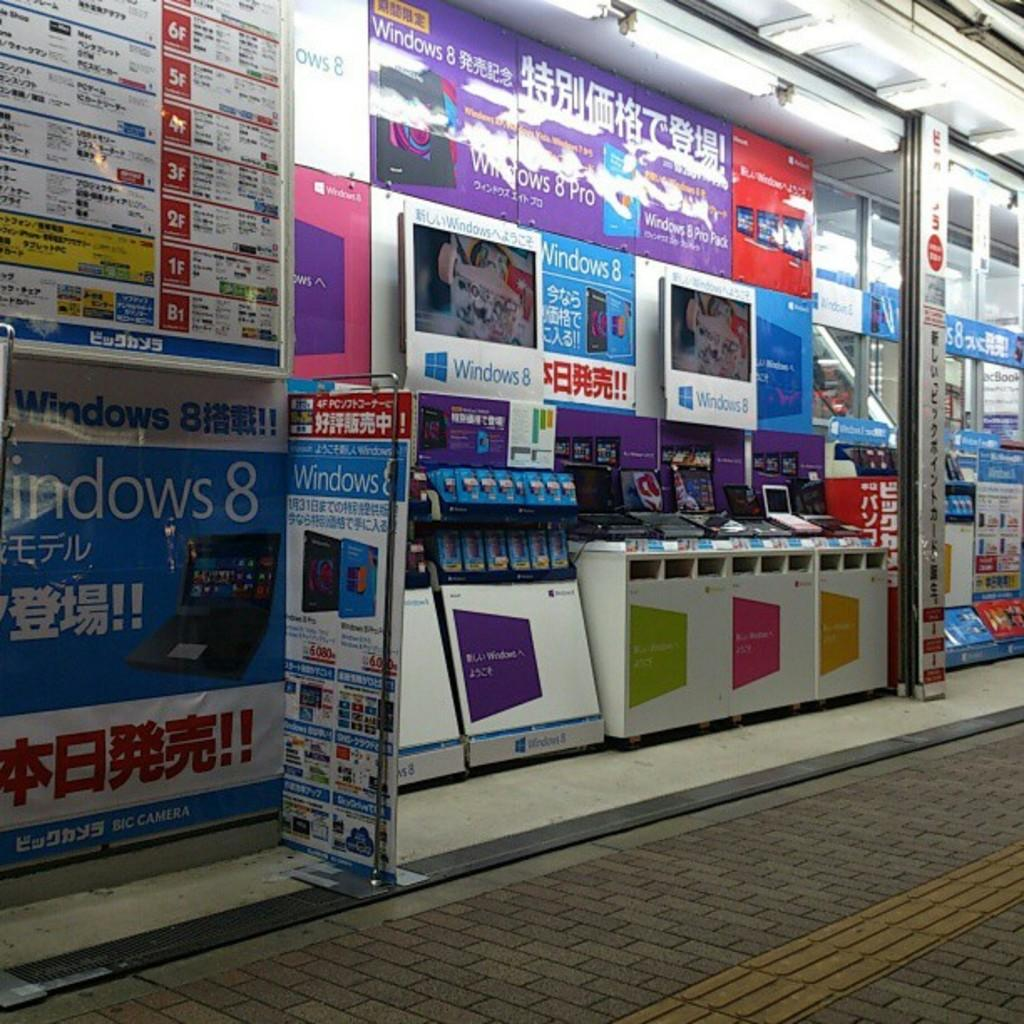<image>
Present a compact description of the photo's key features. A Windows 8 ad is on a wall covered in signs and ads. 